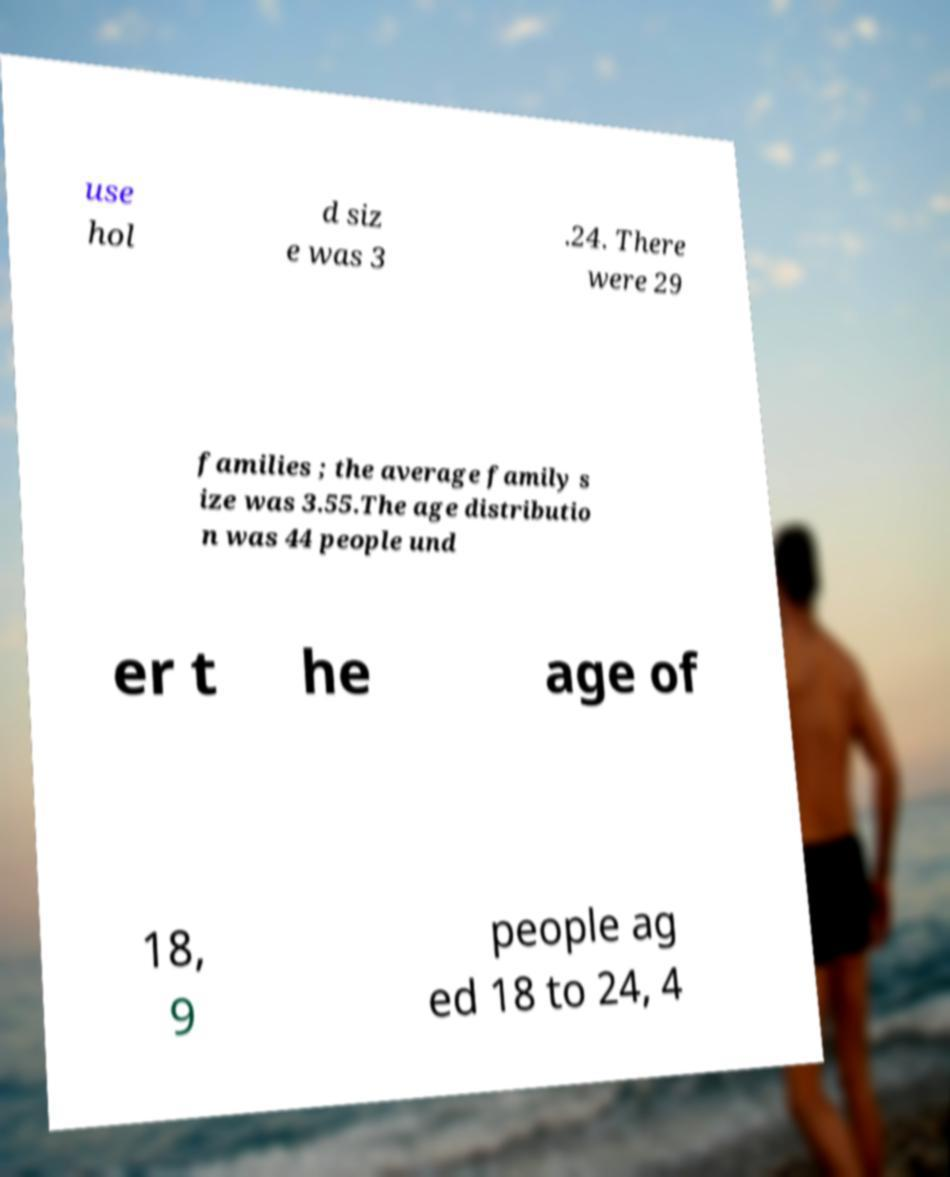Can you accurately transcribe the text from the provided image for me? use hol d siz e was 3 .24. There were 29 families ; the average family s ize was 3.55.The age distributio n was 44 people und er t he age of 18, 9 people ag ed 18 to 24, 4 